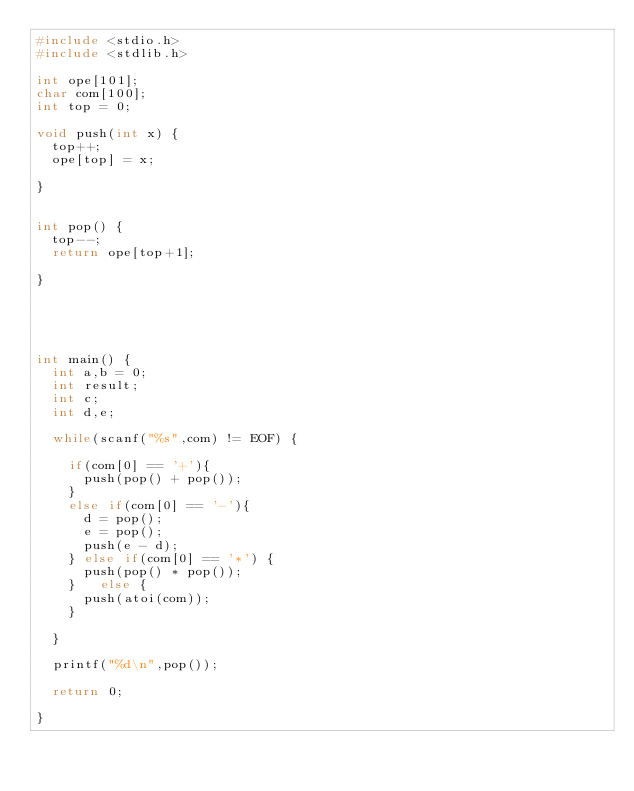<code> <loc_0><loc_0><loc_500><loc_500><_C_>#include <stdio.h>
#include <stdlib.h>
 
int ope[101];
char com[100];
int top = 0;
 
void push(int x) {
  top++;
  ope[top] = x;  
  
}
 
 
int pop() {
  top--;
  return ope[top+1];
   
}
 
   
   
 
   
int main() {
  int a,b = 0;
  int result;
  int c;
  int d,e;
   
  while(scanf("%s",com) != EOF) {
     
    if(com[0] == '+'){ 
      push(pop() + pop());
    }
    else if(com[0] == '-'){
      d = pop();
      e = pop();
      push(e - d);
    } else if(com[0] == '*') {
      push(pop() * pop());
    }   else {
      push(atoi(com));
    }
     
  }
 
  printf("%d\n",pop());
 
  return 0;
   
}
</code> 